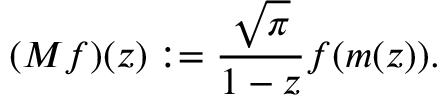<formula> <loc_0><loc_0><loc_500><loc_500>( M f ) ( z ) \colon = { \frac { \sqrt { \pi } } { 1 - z } } f ( m ( z ) ) .</formula> 